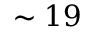<formula> <loc_0><loc_0><loc_500><loc_500>\sim 1 9</formula> 